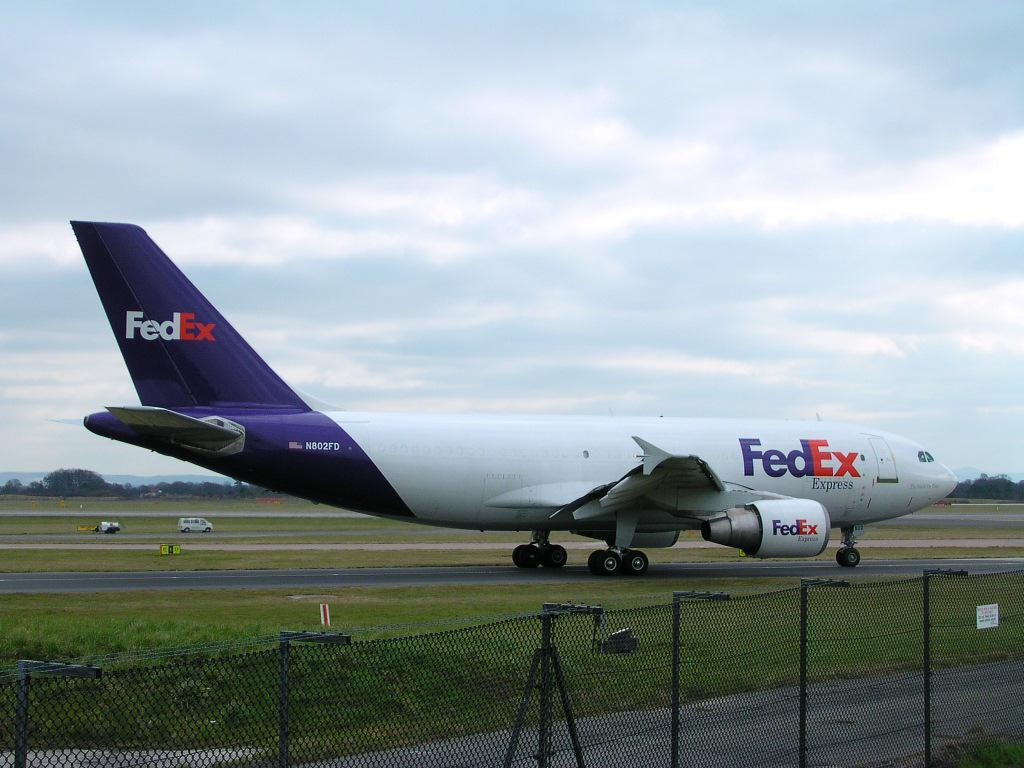<image>
Offer a succinct explanation of the picture presented. A FedEx plane is on a runway on a cloudy day. 